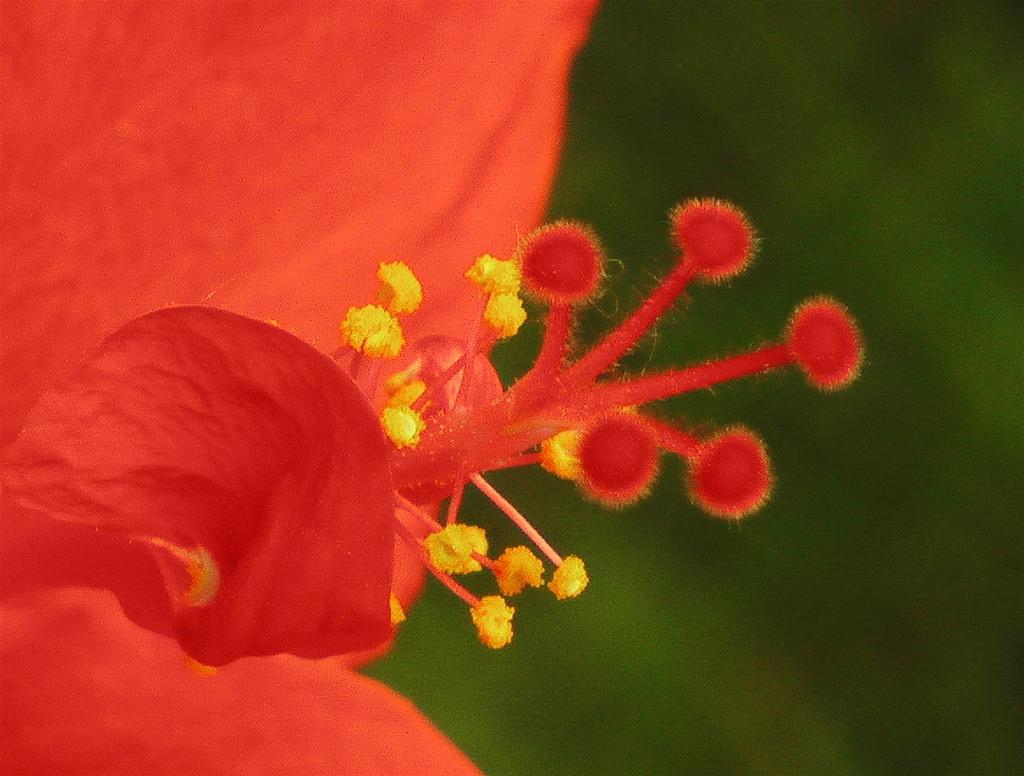What is the main subject of the image? The main subject of the image is a flower. Can you describe the background of the flower? The background of the flower is blue. What type of trousers can be seen hanging on the flower in the image? There are no trousers present in the image; it is a zoomed-in picture of a flower with a blue background. 